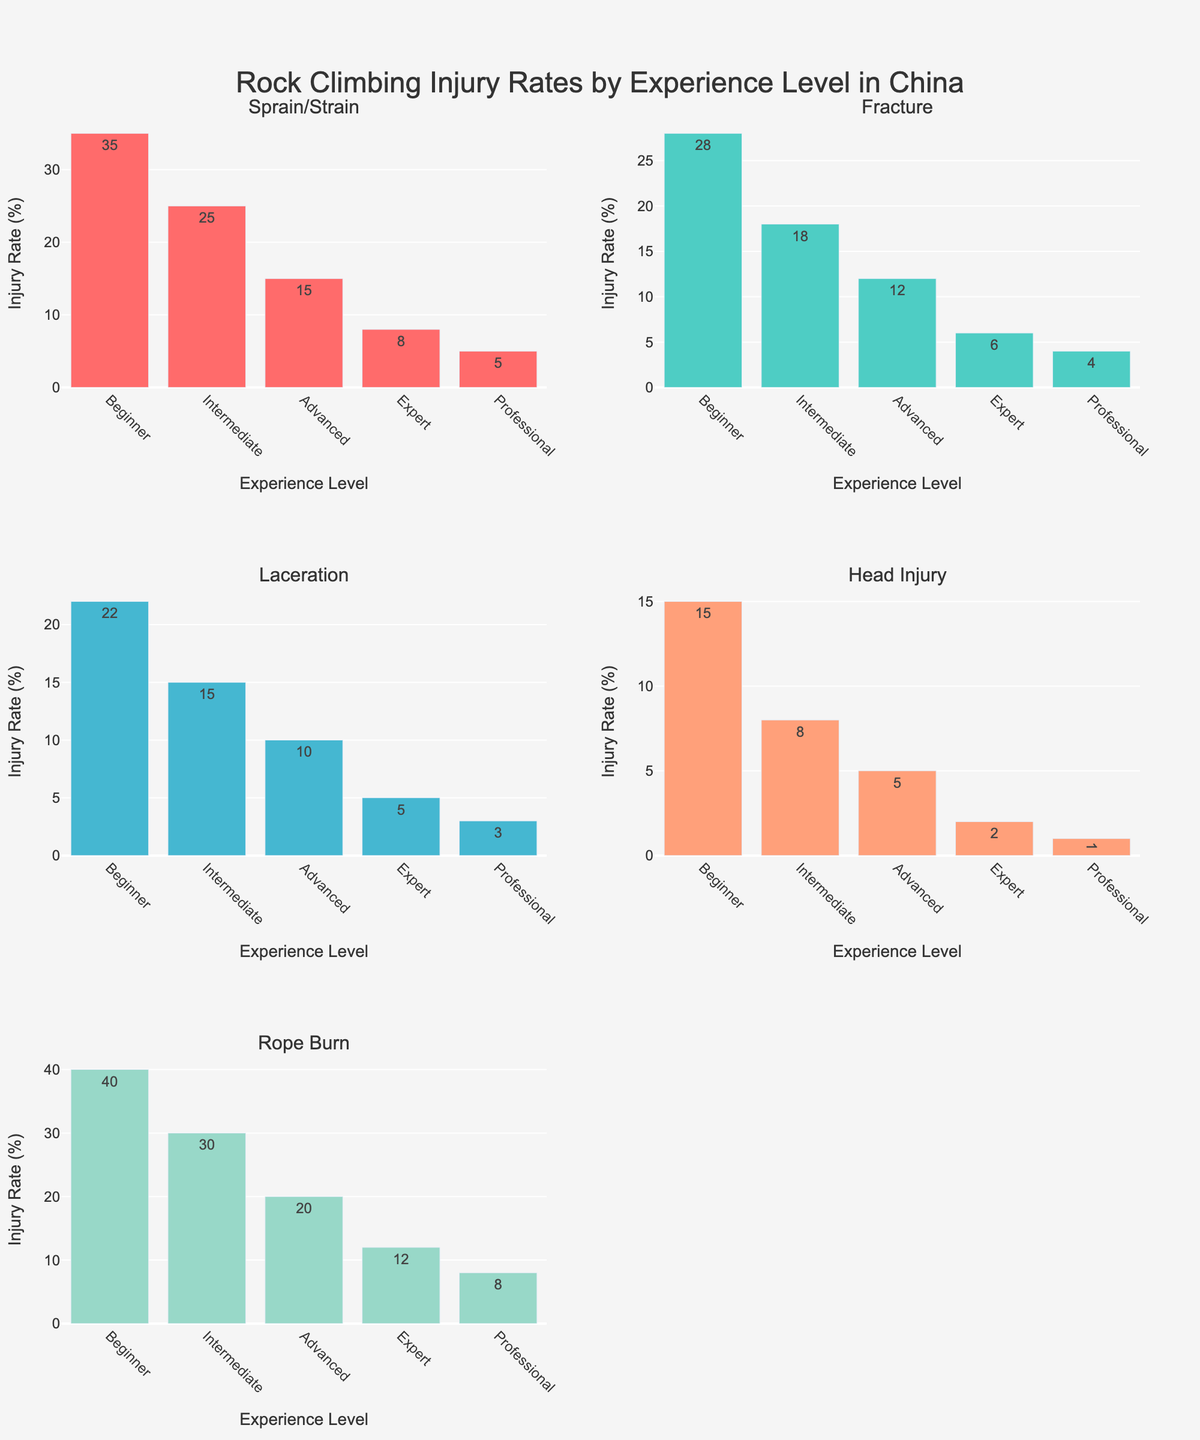How many types of injuries are displayed in the figure? The figure titles indicate the types of injuries displayed. Counting them gives us five types: Sprain/Strain, Fracture, Laceration, Head Injury, Rope Burn.
Answer: Five For which injury type does the 'Beginner' experience level have the highest injury rate? Looking at the 'Beginner' bars in each subplot, the 'Rope Burn' section has the highest bar with a value of 40.
Answer: Rope Burn What is the injury rate of 'Head Injury' for the 'Advanced' climbers? In the subplot for 'Head Injury', locate the bar corresponding to 'Advanced' climbers, which shows the value 5.
Answer: 5 Which experience level has the lowest rate of 'Fracture' injuries? By scanning the 'Fracture' subplot, the 'Professional' experience level has the smallest bar at a value of 4.
Answer: Professional What is the total injury rate for 'Intermediate' climbers across all injury types? Summing up the values for 'Intermediate' climbers: 25 (Sprain/Strain) + 18 (Fracture) + 15 (Laceration) + 8 (Head Injury) + 30 (Rope Burn) = 96.
Answer: 96 Among 'Sprain/Strain' and 'Fracture', which injury type has a higher rate for 'Expert' climbers and by how much? Comparing the 'Expert' bars in 'Sprain/Strain' (8) and 'Fracture' (6), 'Sprain/Strain' is higher by 8 - 6 = 2.
Answer: Sprain/Strain, 2 What is the average injury rate for 'Laceration' across all experience levels? Summing the 'Laceration' values: 22 + 15 + 10 + 5 + 3 = 55 and dividing by 5 levels gives 55 / 5 = 11.
Answer: 11 How does the rate of 'Head Injury' for 'Professional' climbers compare to that of 'Intermediate' climbers? The 'Head Injury' rate for 'Professional' climbers is 1, while for 'Intermediate' climbers it is 8. So, 'Professional' climbers have a 7-point lower rate.
Answer: Professional climbers have a lower rate by 7 In which injury type subplot is the difference between 'Beginner' and 'Professional' injury rates the greatest? Calculate the differences: Sprain/Strain (35-5=30), Fracture (28-4=24), Laceration (22-3=19), Head Injury (15-1=14), Rope Burn (40-8=32); the 'Rope Burn' has the greatest difference of 32.
Answer: Rope Burn What trend can be observed about injury rates as climber experience increases? Across the subplots, the bars generally decrease in height as the experience level increases, indicating a decline in injury rates with increased experience.
Answer: Decline in injury rates 